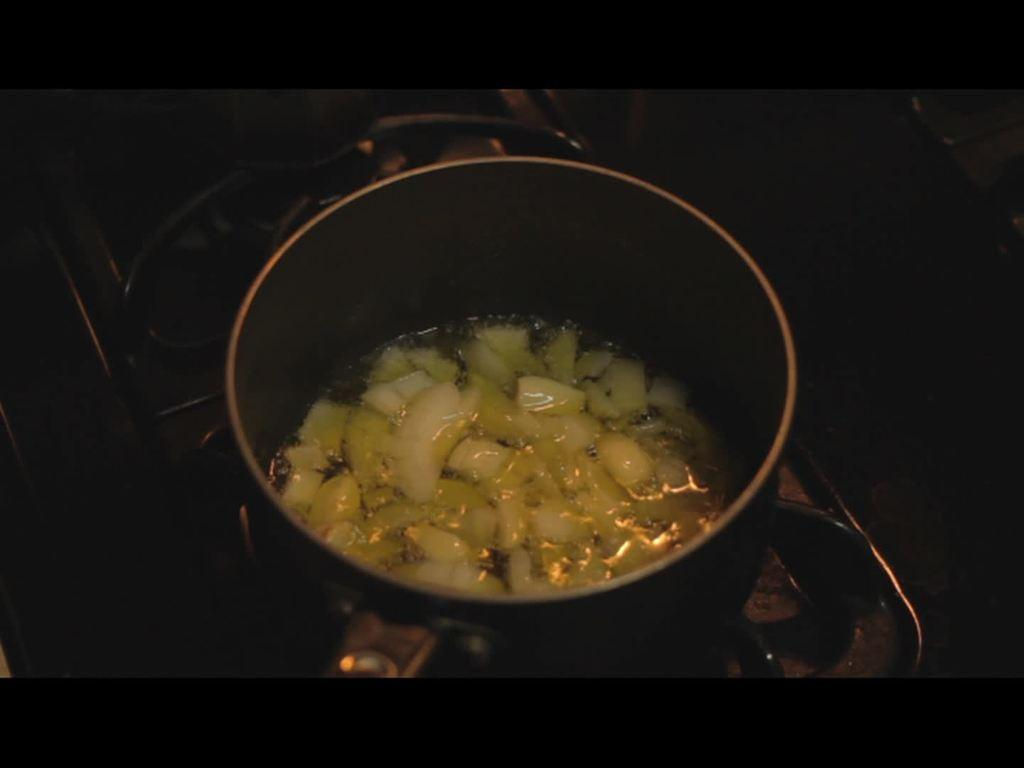What is the main object in the image? There is a stove in the image. What is placed on the stove? There is a vessel on the stove. What is happening to the contents of the vessel? Something is being cooked in the vessel. What type of rose is growing on the stove in the image? There is no rose present in the image; it features a stove with a vessel on it. Can you tell me how many airplanes are flying over the stove in the image? There are no airplanes present in the image; it only features a stove with a vessel on it. 